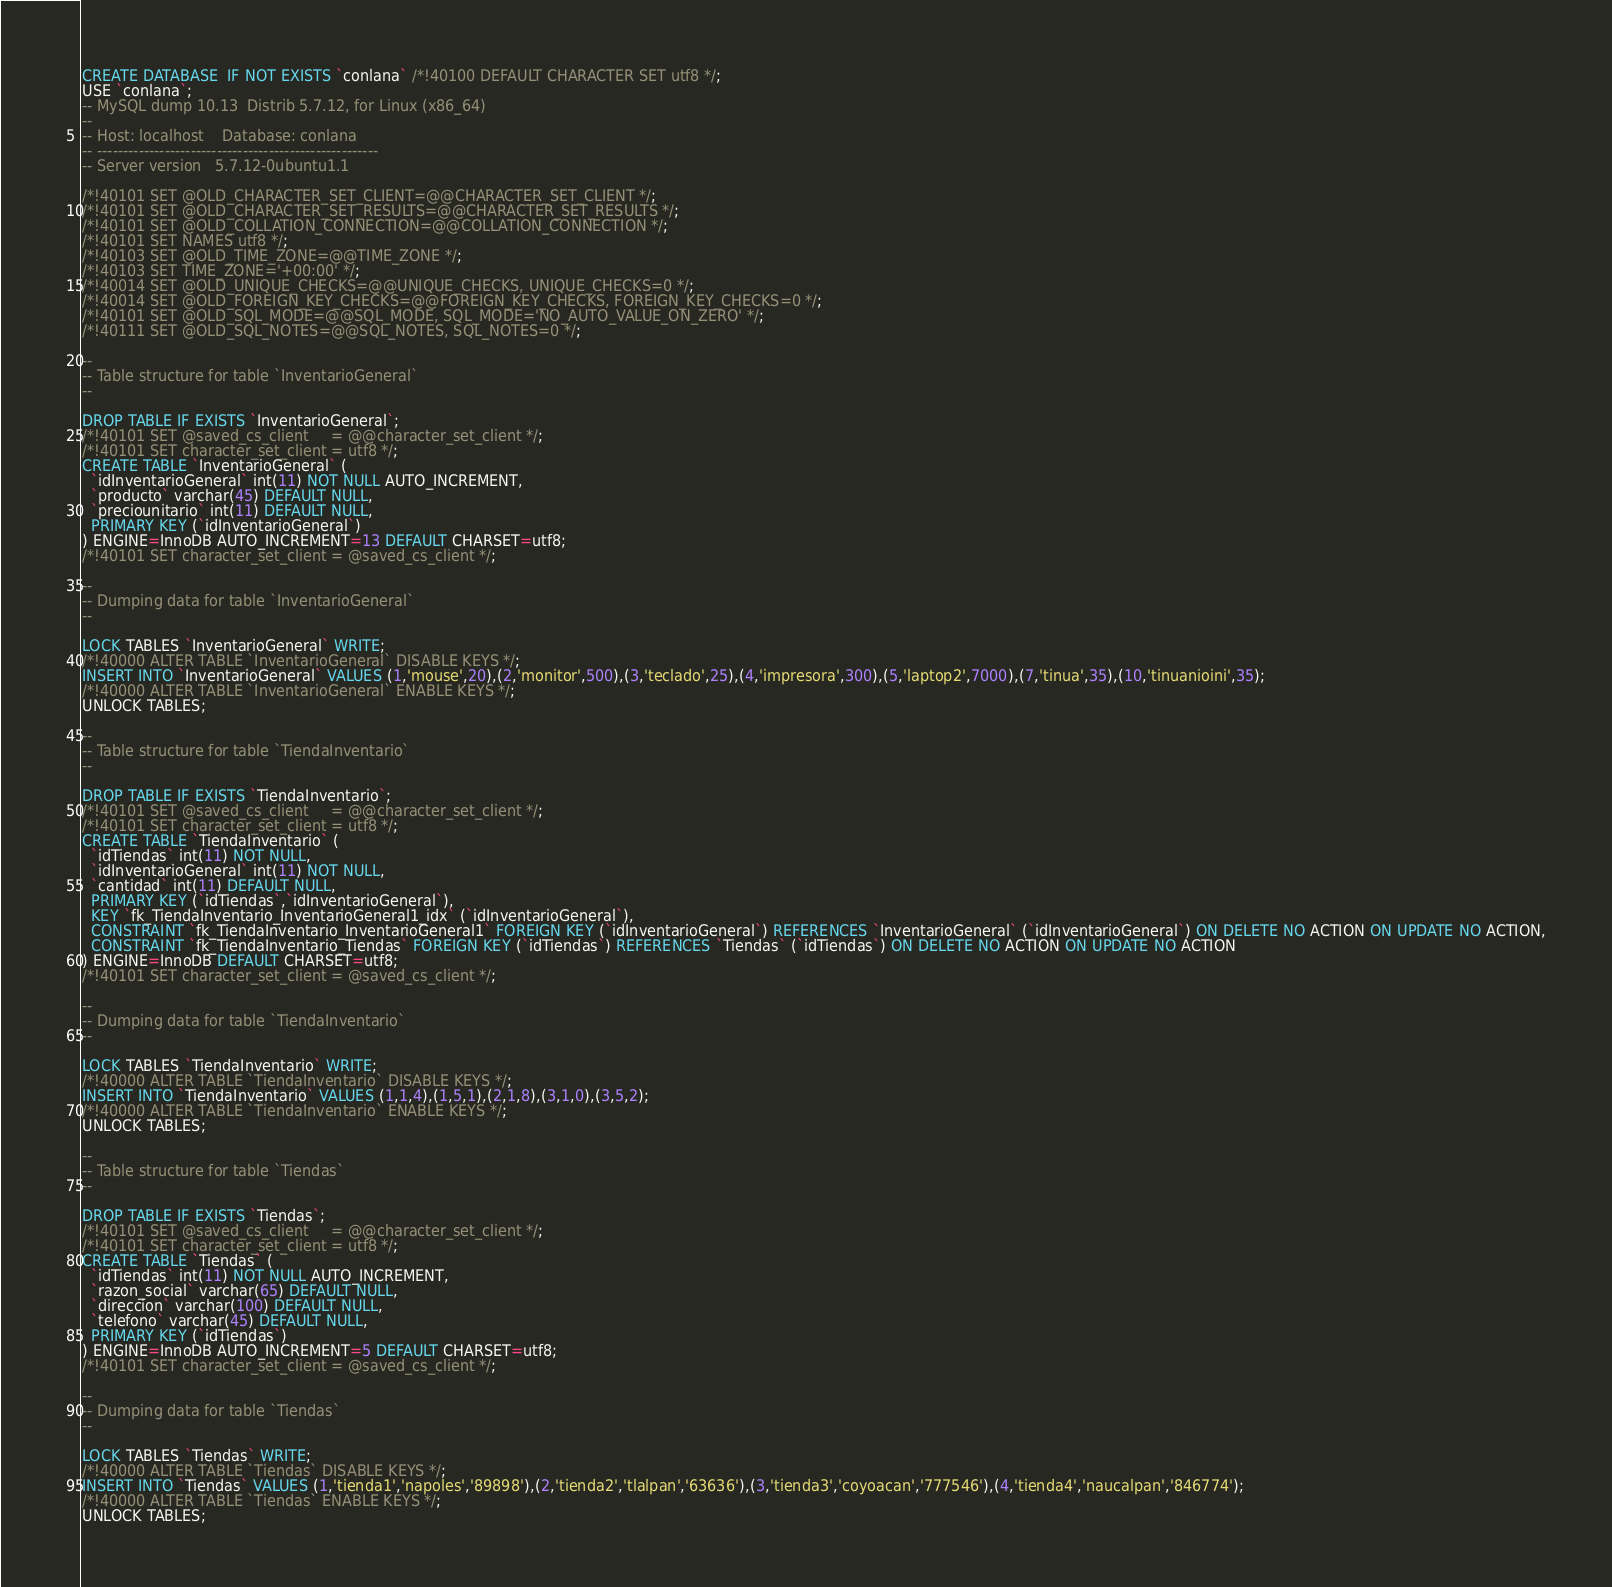Convert code to text. <code><loc_0><loc_0><loc_500><loc_500><_SQL_>CREATE DATABASE  IF NOT EXISTS `conlana` /*!40100 DEFAULT CHARACTER SET utf8 */;
USE `conlana`;
-- MySQL dump 10.13  Distrib 5.7.12, for Linux (x86_64)
--
-- Host: localhost    Database: conlana
-- ------------------------------------------------------
-- Server version	5.7.12-0ubuntu1.1

/*!40101 SET @OLD_CHARACTER_SET_CLIENT=@@CHARACTER_SET_CLIENT */;
/*!40101 SET @OLD_CHARACTER_SET_RESULTS=@@CHARACTER_SET_RESULTS */;
/*!40101 SET @OLD_COLLATION_CONNECTION=@@COLLATION_CONNECTION */;
/*!40101 SET NAMES utf8 */;
/*!40103 SET @OLD_TIME_ZONE=@@TIME_ZONE */;
/*!40103 SET TIME_ZONE='+00:00' */;
/*!40014 SET @OLD_UNIQUE_CHECKS=@@UNIQUE_CHECKS, UNIQUE_CHECKS=0 */;
/*!40014 SET @OLD_FOREIGN_KEY_CHECKS=@@FOREIGN_KEY_CHECKS, FOREIGN_KEY_CHECKS=0 */;
/*!40101 SET @OLD_SQL_MODE=@@SQL_MODE, SQL_MODE='NO_AUTO_VALUE_ON_ZERO' */;
/*!40111 SET @OLD_SQL_NOTES=@@SQL_NOTES, SQL_NOTES=0 */;

--
-- Table structure for table `InventarioGeneral`
--

DROP TABLE IF EXISTS `InventarioGeneral`;
/*!40101 SET @saved_cs_client     = @@character_set_client */;
/*!40101 SET character_set_client = utf8 */;
CREATE TABLE `InventarioGeneral` (
  `idInventarioGeneral` int(11) NOT NULL AUTO_INCREMENT,
  `producto` varchar(45) DEFAULT NULL,
  `preciounitario` int(11) DEFAULT NULL,
  PRIMARY KEY (`idInventarioGeneral`)
) ENGINE=InnoDB AUTO_INCREMENT=13 DEFAULT CHARSET=utf8;
/*!40101 SET character_set_client = @saved_cs_client */;

--
-- Dumping data for table `InventarioGeneral`
--

LOCK TABLES `InventarioGeneral` WRITE;
/*!40000 ALTER TABLE `InventarioGeneral` DISABLE KEYS */;
INSERT INTO `InventarioGeneral` VALUES (1,'mouse',20),(2,'monitor',500),(3,'teclado',25),(4,'impresora',300),(5,'laptop2',7000),(7,'tinua',35),(10,'tinuanioini',35);
/*!40000 ALTER TABLE `InventarioGeneral` ENABLE KEYS */;
UNLOCK TABLES;

--
-- Table structure for table `TiendaInventario`
--

DROP TABLE IF EXISTS `TiendaInventario`;
/*!40101 SET @saved_cs_client     = @@character_set_client */;
/*!40101 SET character_set_client = utf8 */;
CREATE TABLE `TiendaInventario` (
  `idTiendas` int(11) NOT NULL,
  `idInventarioGeneral` int(11) NOT NULL,
  `cantidad` int(11) DEFAULT NULL,
  PRIMARY KEY (`idTiendas`,`idInventarioGeneral`),
  KEY `fk_TiendaInventario_InventarioGeneral1_idx` (`idInventarioGeneral`),
  CONSTRAINT `fk_TiendaInventario_InventarioGeneral1` FOREIGN KEY (`idInventarioGeneral`) REFERENCES `InventarioGeneral` (`idInventarioGeneral`) ON DELETE NO ACTION ON UPDATE NO ACTION,
  CONSTRAINT `fk_TiendaInventario_Tiendas` FOREIGN KEY (`idTiendas`) REFERENCES `Tiendas` (`idTiendas`) ON DELETE NO ACTION ON UPDATE NO ACTION
) ENGINE=InnoDB DEFAULT CHARSET=utf8;
/*!40101 SET character_set_client = @saved_cs_client */;

--
-- Dumping data for table `TiendaInventario`
--

LOCK TABLES `TiendaInventario` WRITE;
/*!40000 ALTER TABLE `TiendaInventario` DISABLE KEYS */;
INSERT INTO `TiendaInventario` VALUES (1,1,4),(1,5,1),(2,1,8),(3,1,0),(3,5,2);
/*!40000 ALTER TABLE `TiendaInventario` ENABLE KEYS */;
UNLOCK TABLES;

--
-- Table structure for table `Tiendas`
--

DROP TABLE IF EXISTS `Tiendas`;
/*!40101 SET @saved_cs_client     = @@character_set_client */;
/*!40101 SET character_set_client = utf8 */;
CREATE TABLE `Tiendas` (
  `idTiendas` int(11) NOT NULL AUTO_INCREMENT,
  `razon_social` varchar(65) DEFAULT NULL,
  `direccion` varchar(100) DEFAULT NULL,
  `telefono` varchar(45) DEFAULT NULL,
  PRIMARY KEY (`idTiendas`)
) ENGINE=InnoDB AUTO_INCREMENT=5 DEFAULT CHARSET=utf8;
/*!40101 SET character_set_client = @saved_cs_client */;

--
-- Dumping data for table `Tiendas`
--

LOCK TABLES `Tiendas` WRITE;
/*!40000 ALTER TABLE `Tiendas` DISABLE KEYS */;
INSERT INTO `Tiendas` VALUES (1,'tienda1','napoles','89898'),(2,'tienda2','tlalpan','63636'),(3,'tienda3','coyoacan','777546'),(4,'tienda4','naucalpan','846774');
/*!40000 ALTER TABLE `Tiendas` ENABLE KEYS */;
UNLOCK TABLES;</code> 